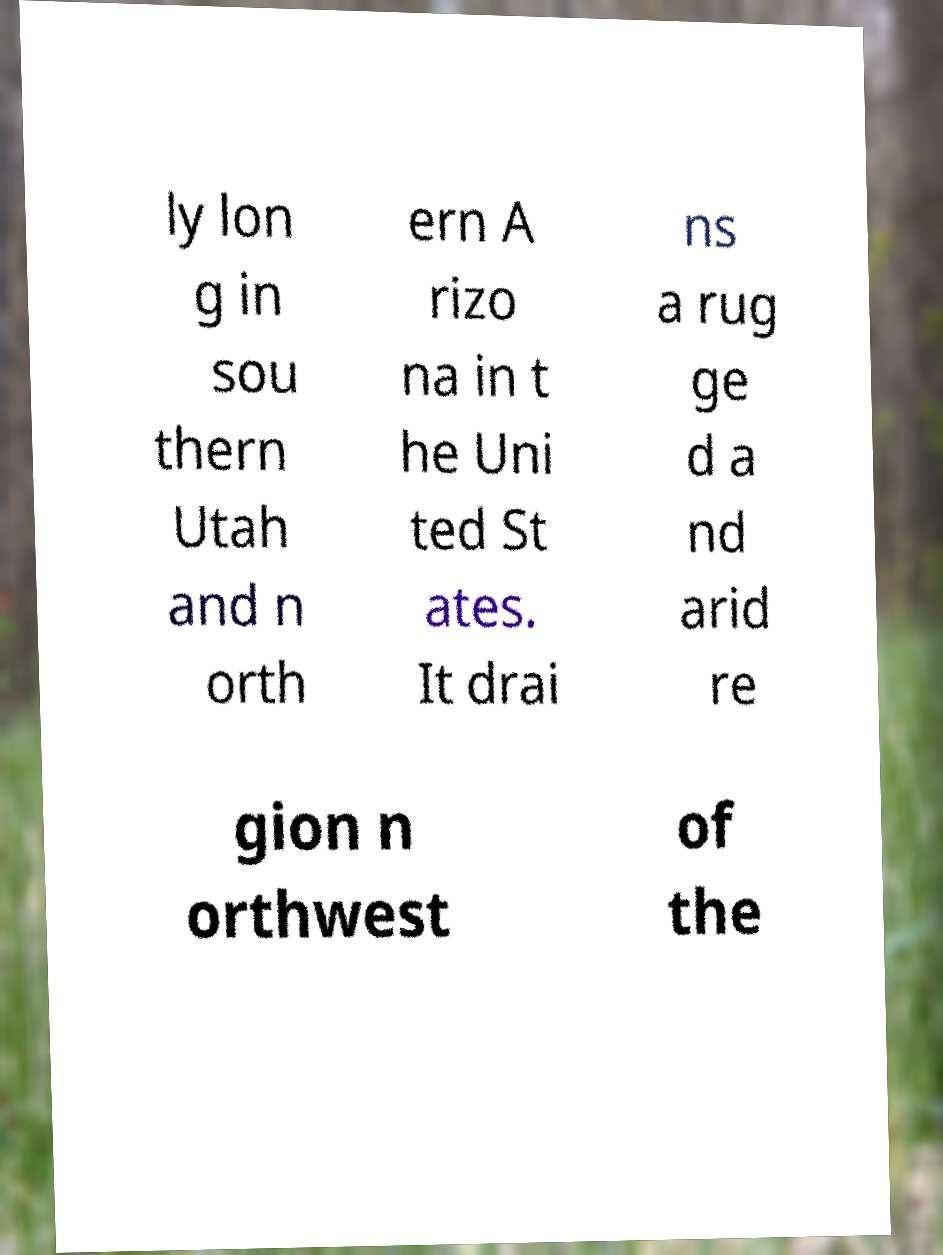Could you extract and type out the text from this image? ly lon g in sou thern Utah and n orth ern A rizo na in t he Uni ted St ates. It drai ns a rug ge d a nd arid re gion n orthwest of the 